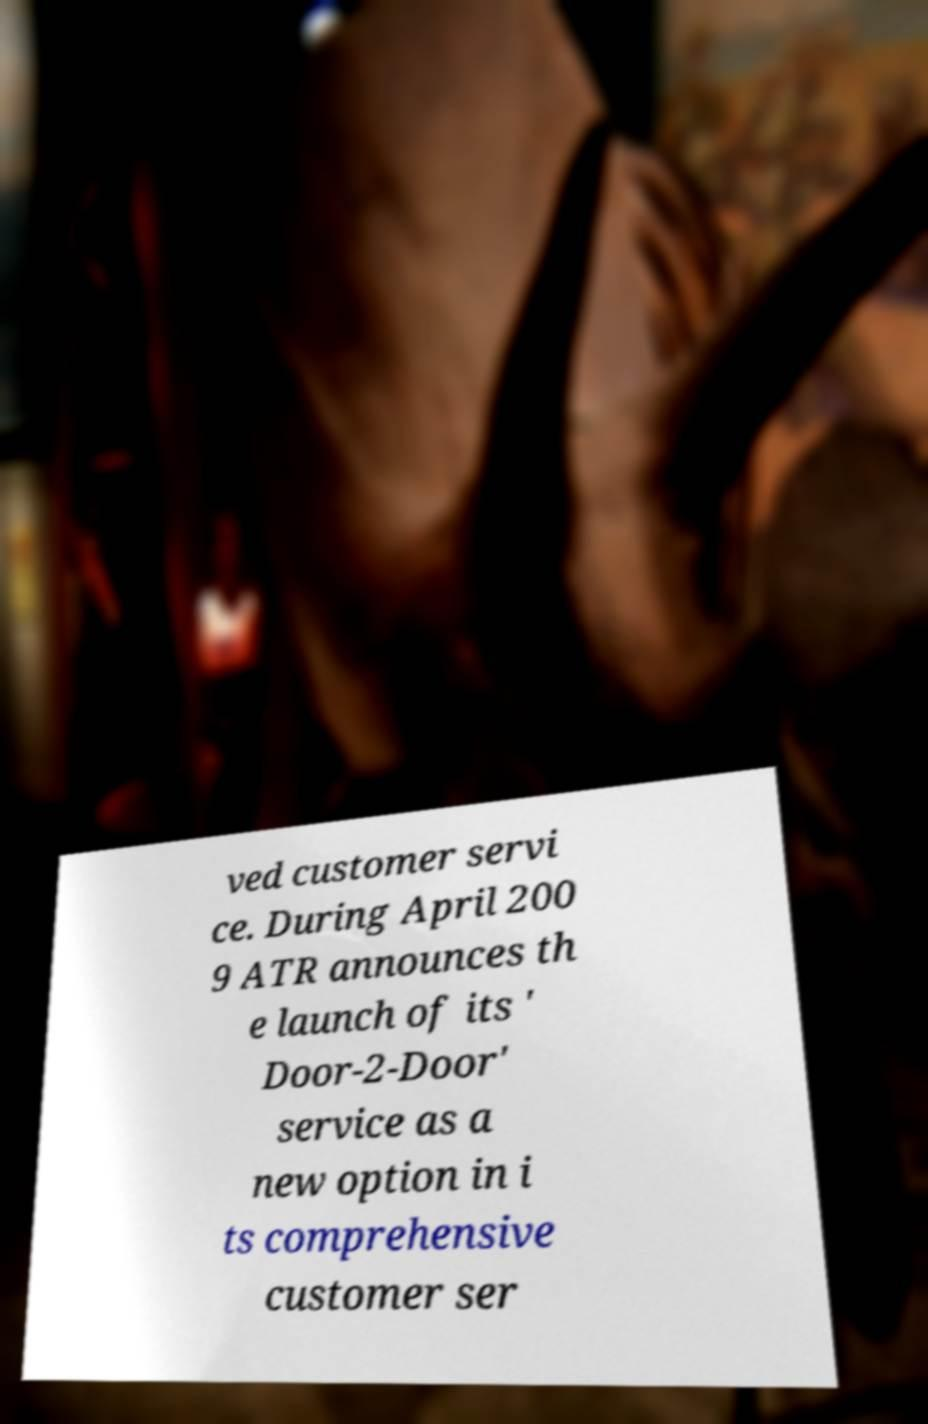What messages or text are displayed in this image? I need them in a readable, typed format. ved customer servi ce. During April 200 9 ATR announces th e launch of its ' Door-2-Door' service as a new option in i ts comprehensive customer ser 